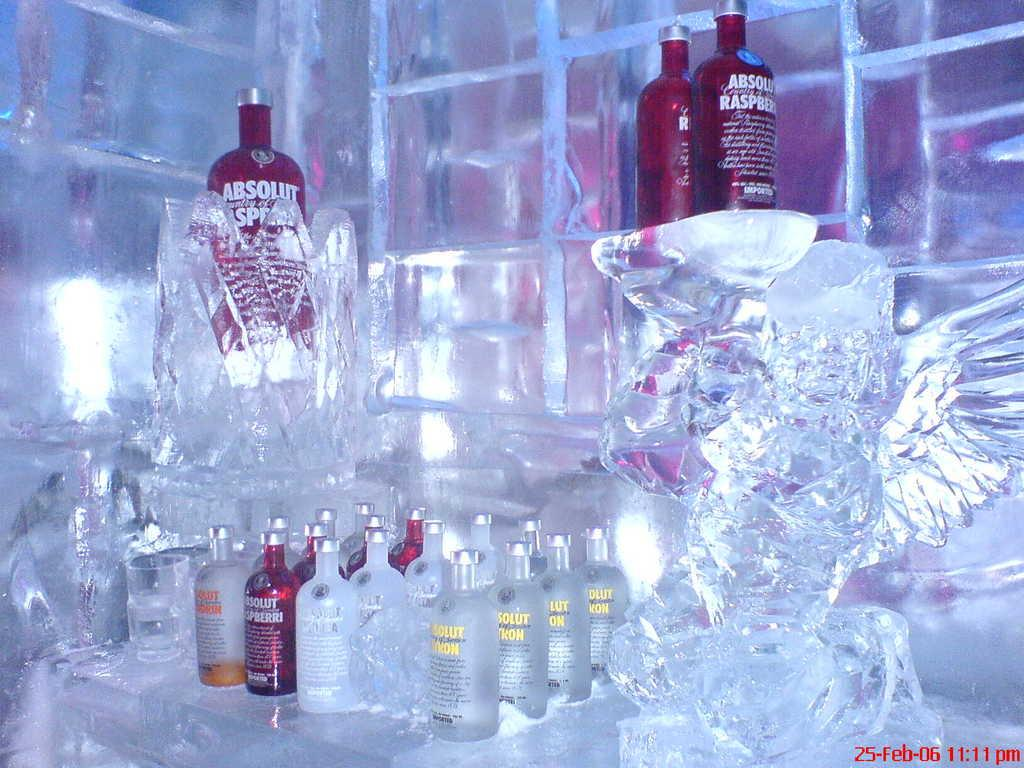<image>
Write a terse but informative summary of the picture. Bottles of Absolute Raspberry sit on ice blocks. 